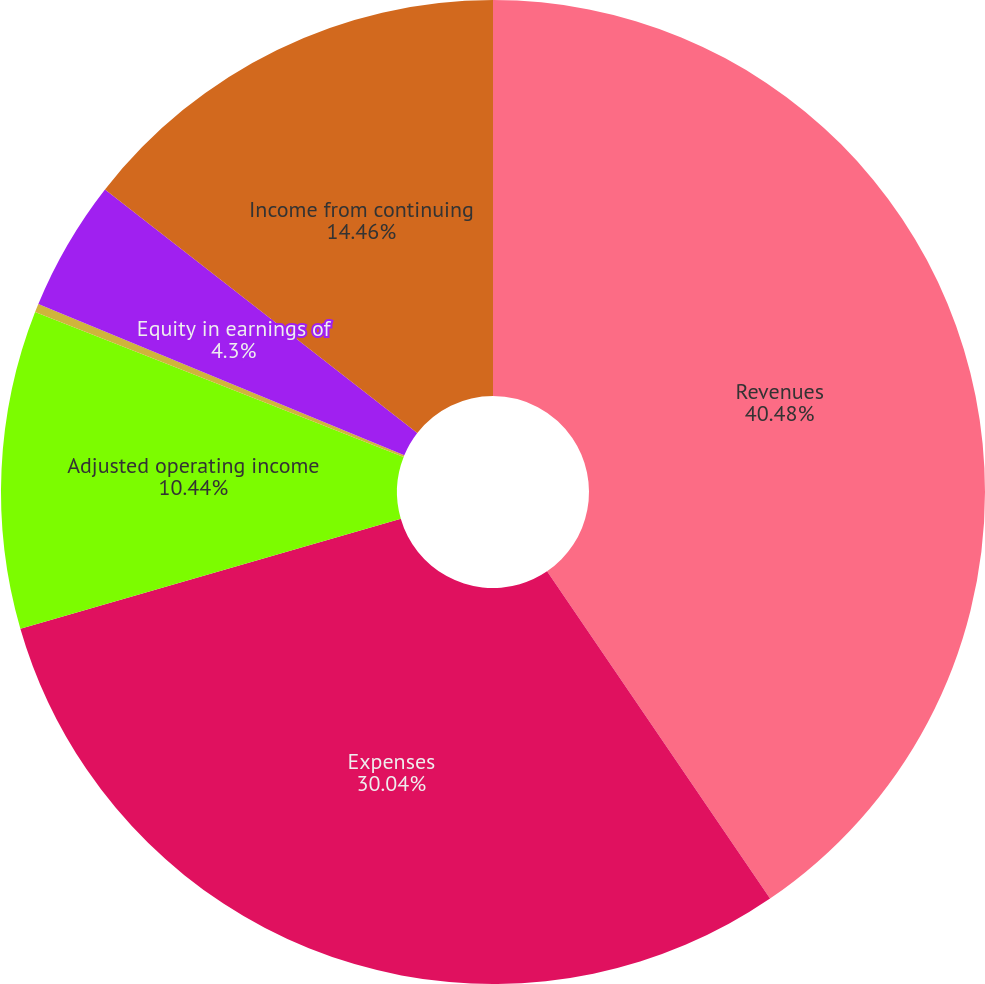<chart> <loc_0><loc_0><loc_500><loc_500><pie_chart><fcel>Revenues<fcel>Expenses<fcel>Adjusted operating income<fcel>Realized investment gains<fcel>Equity in earnings of<fcel>Income from continuing<nl><fcel>40.48%<fcel>30.04%<fcel>10.44%<fcel>0.28%<fcel>4.3%<fcel>14.46%<nl></chart> 